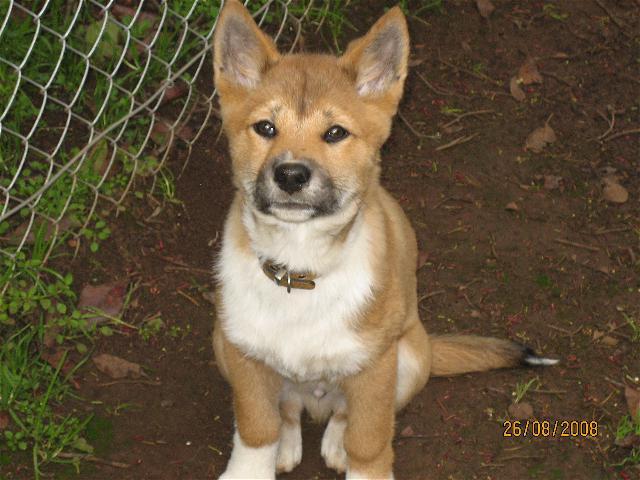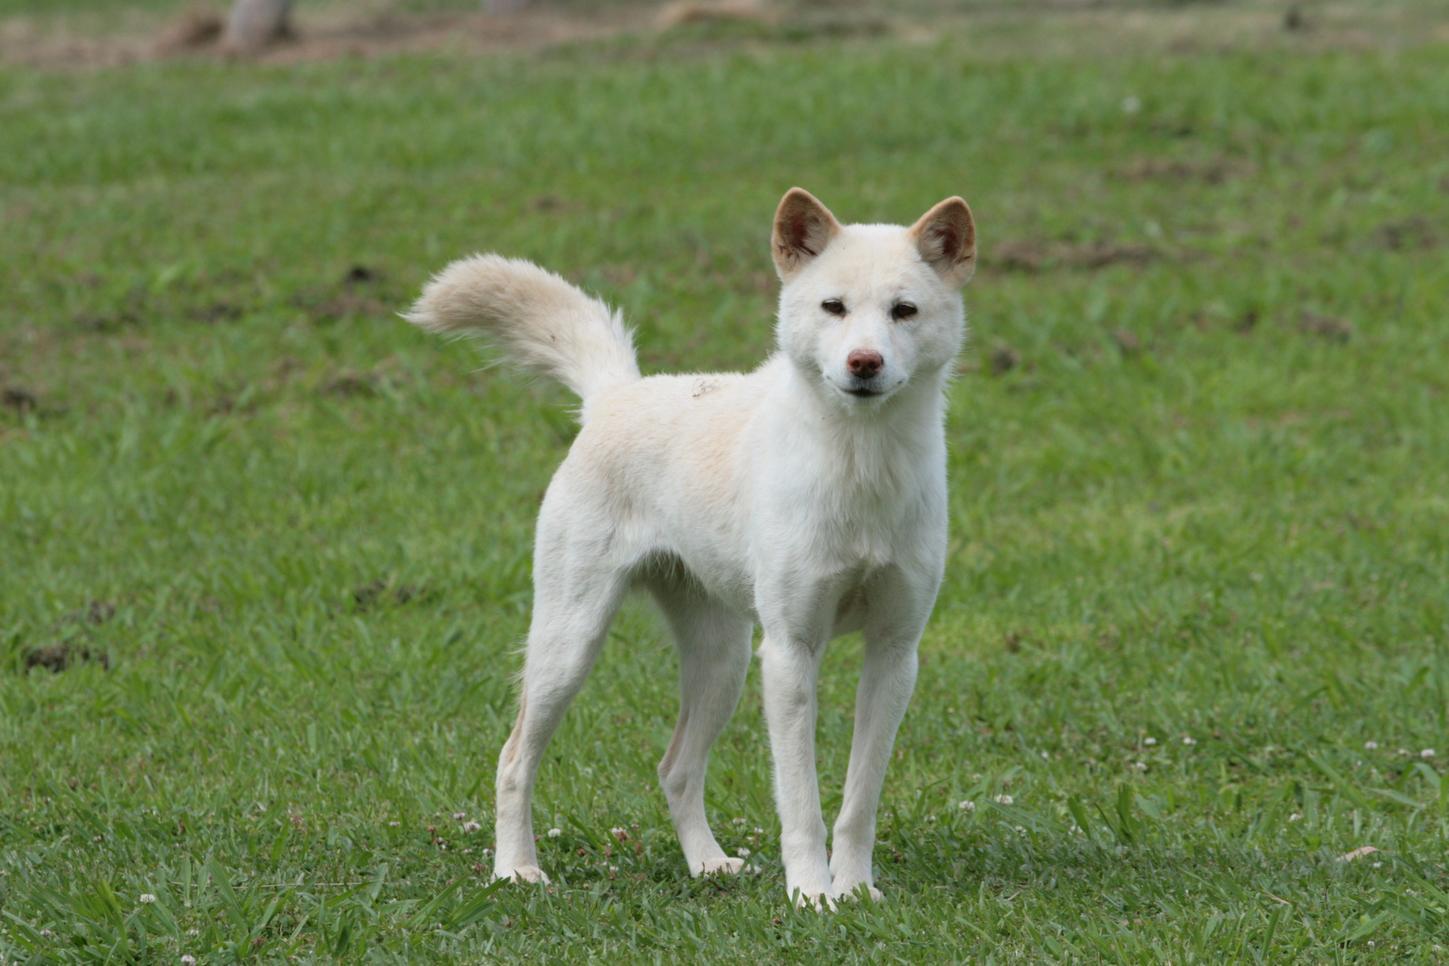The first image is the image on the left, the second image is the image on the right. Given the left and right images, does the statement "Each image contains a single dingo, and one is in an upright sitting pose, while the other is standing on all fours." hold true? Answer yes or no. Yes. The first image is the image on the left, the second image is the image on the right. Given the left and right images, does the statement "Atleast one image of a dog sitting or laying down." hold true? Answer yes or no. Yes. 